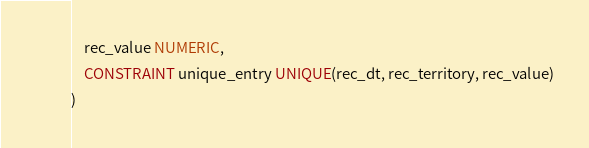Convert code to text. <code><loc_0><loc_0><loc_500><loc_500><_SQL_>    rec_value NUMERIC,
    CONSTRAINT unique_entry UNIQUE(rec_dt, rec_territory, rec_value)
)
</code> 